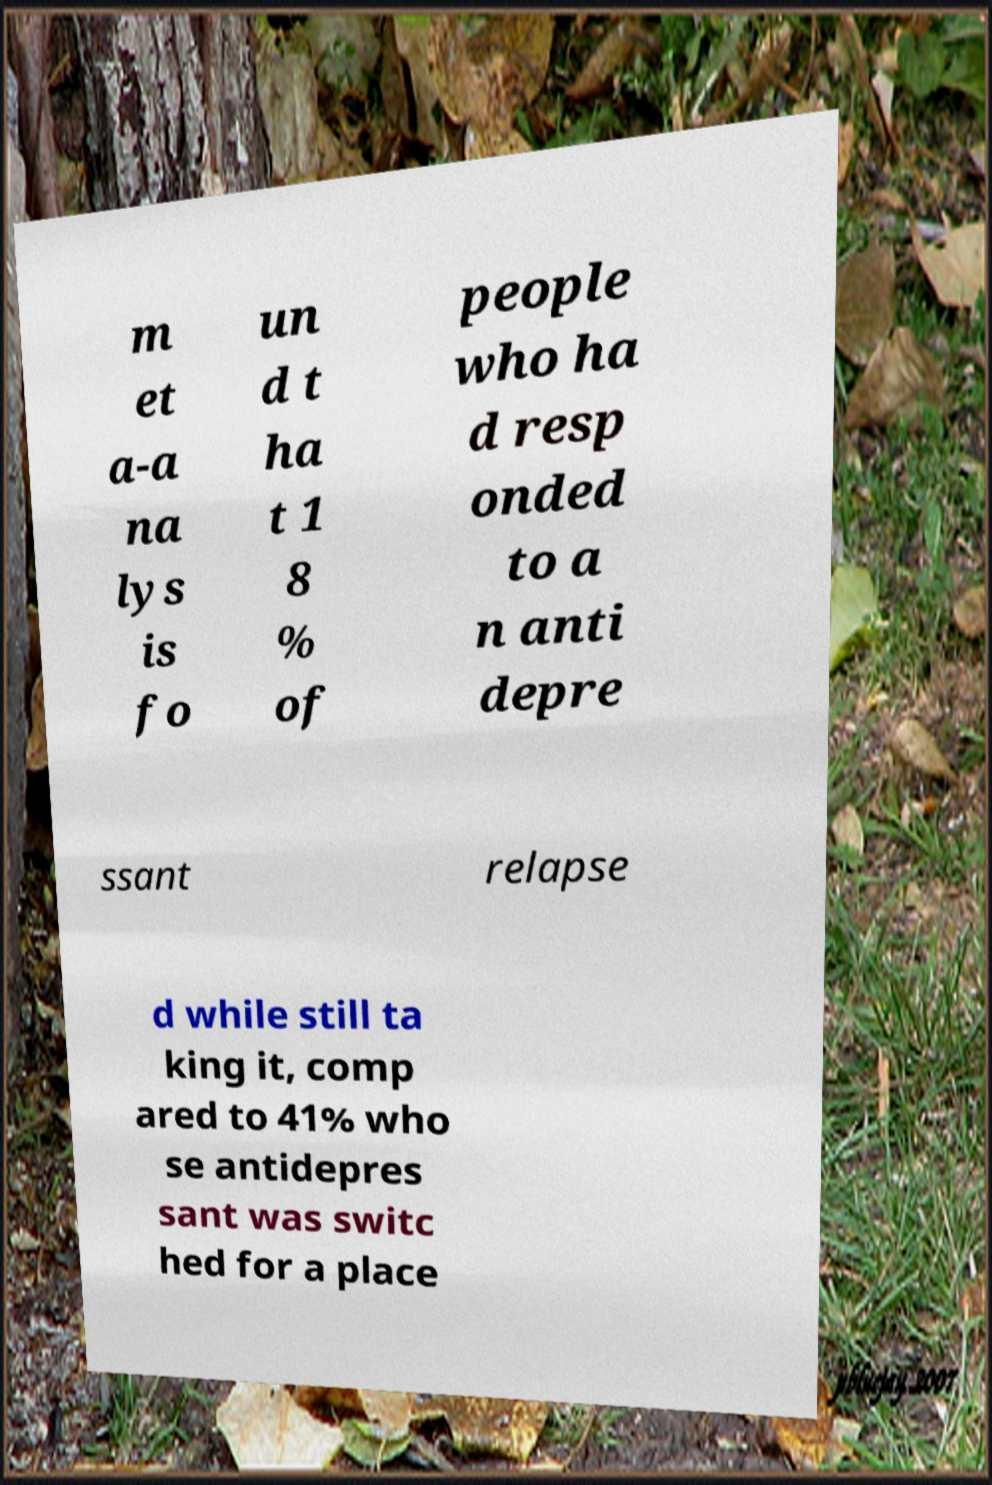I need the written content from this picture converted into text. Can you do that? m et a-a na lys is fo un d t ha t 1 8 % of people who ha d resp onded to a n anti depre ssant relapse d while still ta king it, comp ared to 41% who se antidepres sant was switc hed for a place 